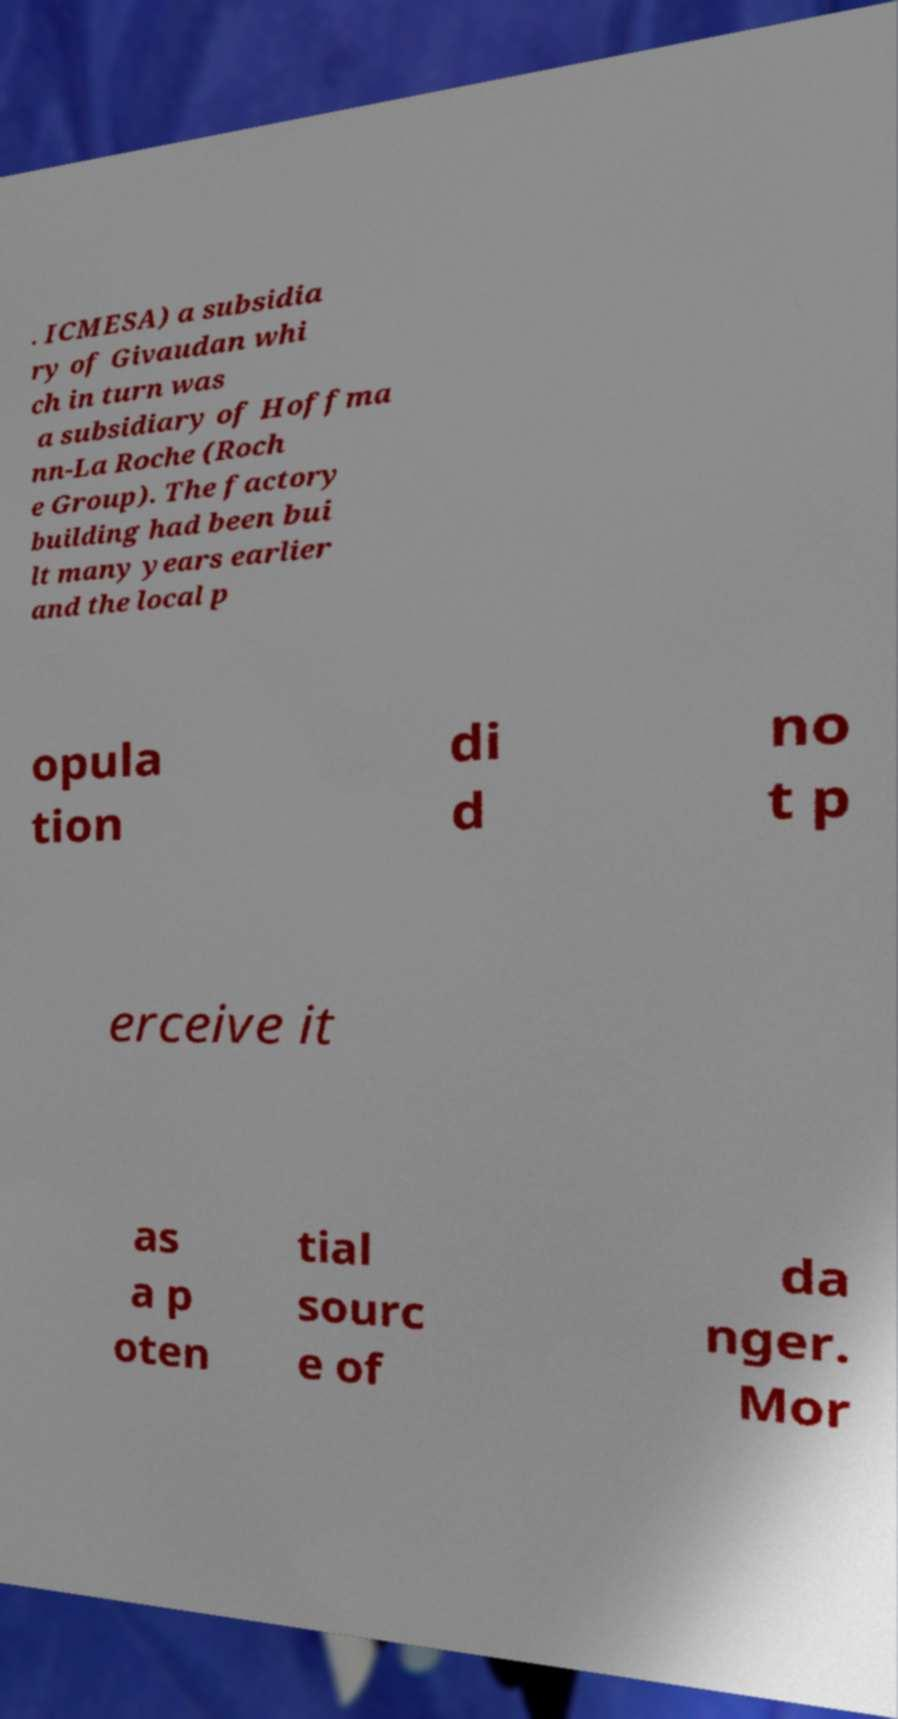Please identify and transcribe the text found in this image. . ICMESA) a subsidia ry of Givaudan whi ch in turn was a subsidiary of Hoffma nn-La Roche (Roch e Group). The factory building had been bui lt many years earlier and the local p opula tion di d no t p erceive it as a p oten tial sourc e of da nger. Mor 